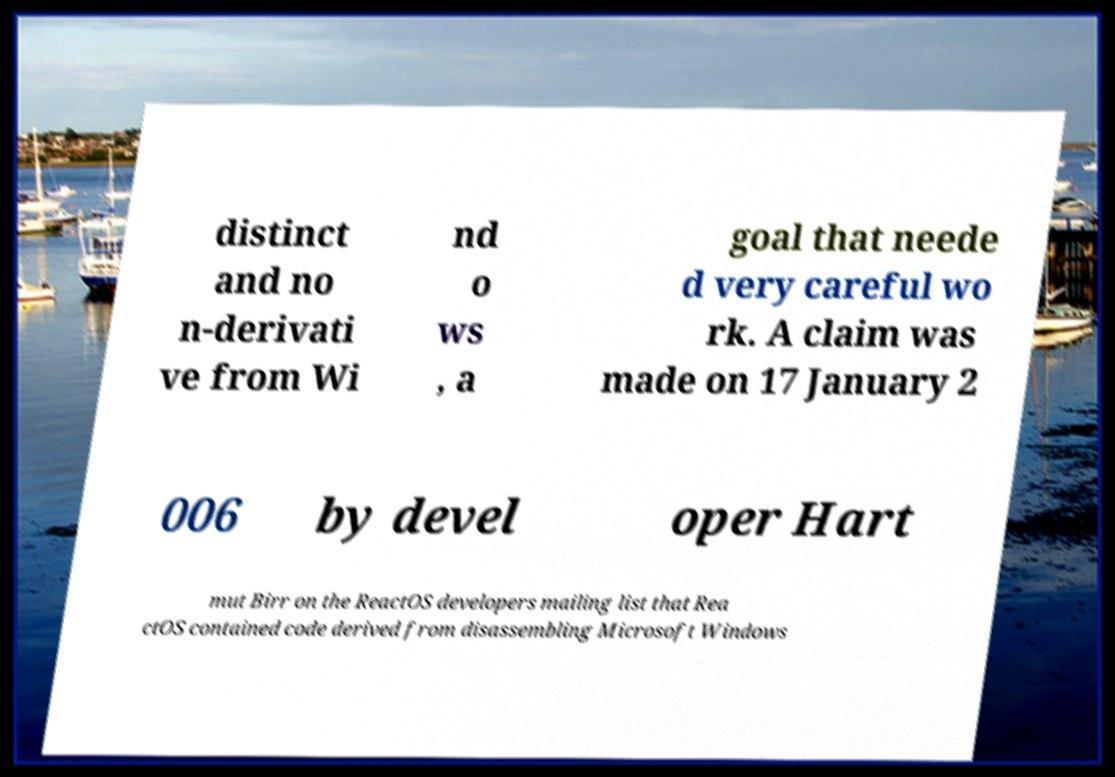Please identify and transcribe the text found in this image. distinct and no n-derivati ve from Wi nd o ws , a goal that neede d very careful wo rk. A claim was made on 17 January 2 006 by devel oper Hart mut Birr on the ReactOS developers mailing list that Rea ctOS contained code derived from disassembling Microsoft Windows 